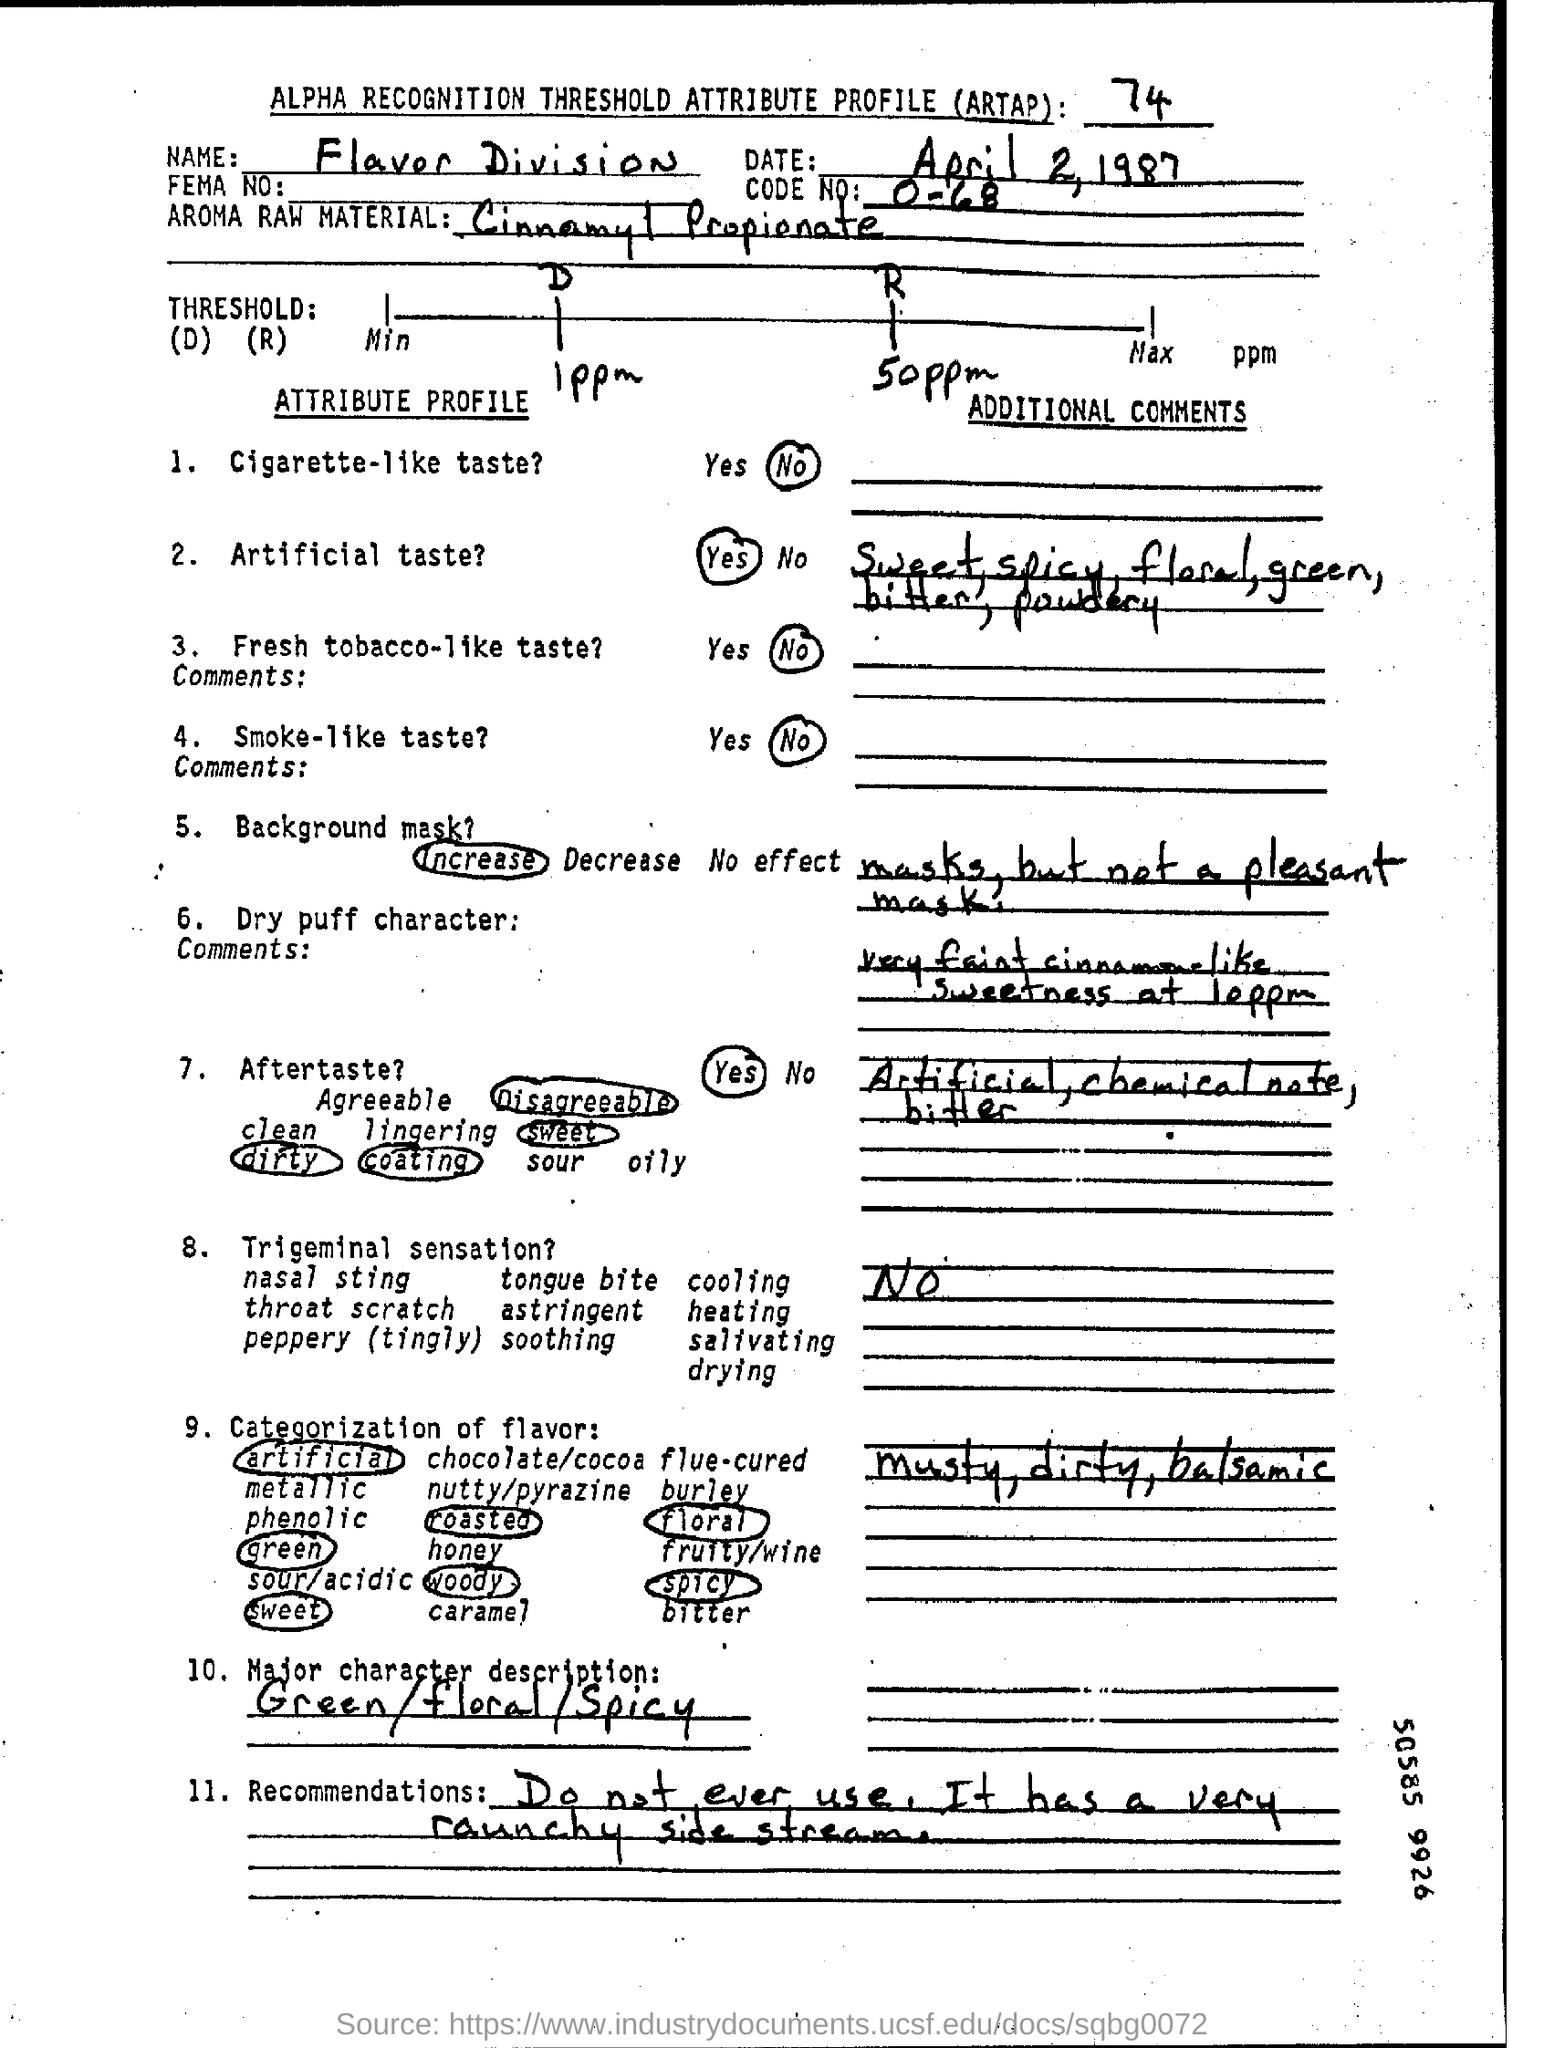Point out several critical features in this image. The code number is O-68. The name written in the name field is Flavor Division. The Major Character description field contains information about the character's personality, such as their appearance, behavior, and traits. This information is usually written in the form of adjectives, such as "green/floral/spicy. 